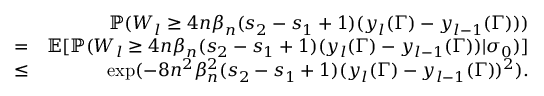<formula> <loc_0><loc_0><loc_500><loc_500>\begin{array} { r l r } & { \mathbb { P } ( W _ { l } \geq 4 n \beta _ { n } ( s _ { 2 } - s _ { 1 } + 1 ) ( y _ { l } ( \Gamma ) - y _ { l - 1 } ( \Gamma ) ) ) } \\ & { = } & { \mathbb { E } [ \mathbb { P } ( W _ { l } \geq 4 n \beta _ { n } ( s _ { 2 } - s _ { 1 } + 1 ) ( y _ { l } ( \Gamma ) - y _ { l - 1 } ( \Gamma ) ) | \sigma _ { 0 } ) ] } \\ & { \leq } & { \exp ( - 8 n ^ { 2 } \beta _ { n } ^ { 2 } ( s _ { 2 } - s _ { 1 } + 1 ) ( y _ { l } ( \Gamma ) - y _ { l - 1 } ( \Gamma ) ) ^ { 2 } ) . } \end{array}</formula> 